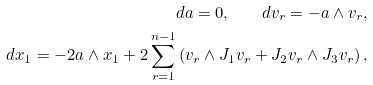Convert formula to latex. <formula><loc_0><loc_0><loc_500><loc_500>d a = 0 , \quad d v _ { r } = - a \wedge v _ { r } , \\ d x _ { 1 } = - 2 a \wedge x _ { 1 } + 2 \sum _ { r = 1 } ^ { n - 1 } \left ( v _ { r } \wedge J _ { 1 } v _ { r } + J _ { 2 } v _ { r } \wedge J _ { 3 } v _ { r } \right ) ,</formula> 